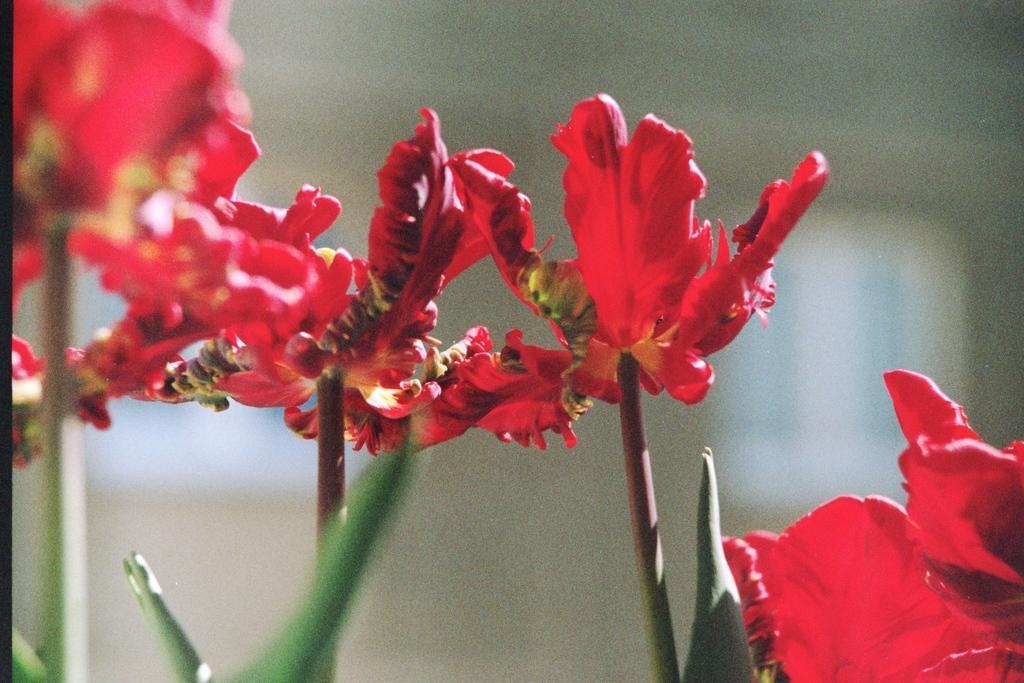In one or two sentences, can you explain what this image depicts? In this image there are flowers to the stems. At the bottom there are leaves. The background is blurry. 